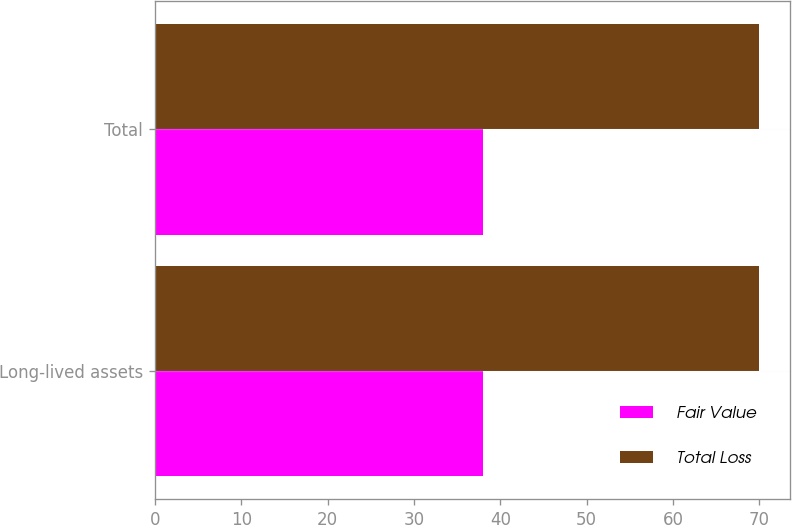Convert chart to OTSL. <chart><loc_0><loc_0><loc_500><loc_500><stacked_bar_chart><ecel><fcel>Long-lived assets<fcel>Total<nl><fcel>Fair Value<fcel>38<fcel>38<nl><fcel>Total Loss<fcel>70<fcel>70<nl></chart> 